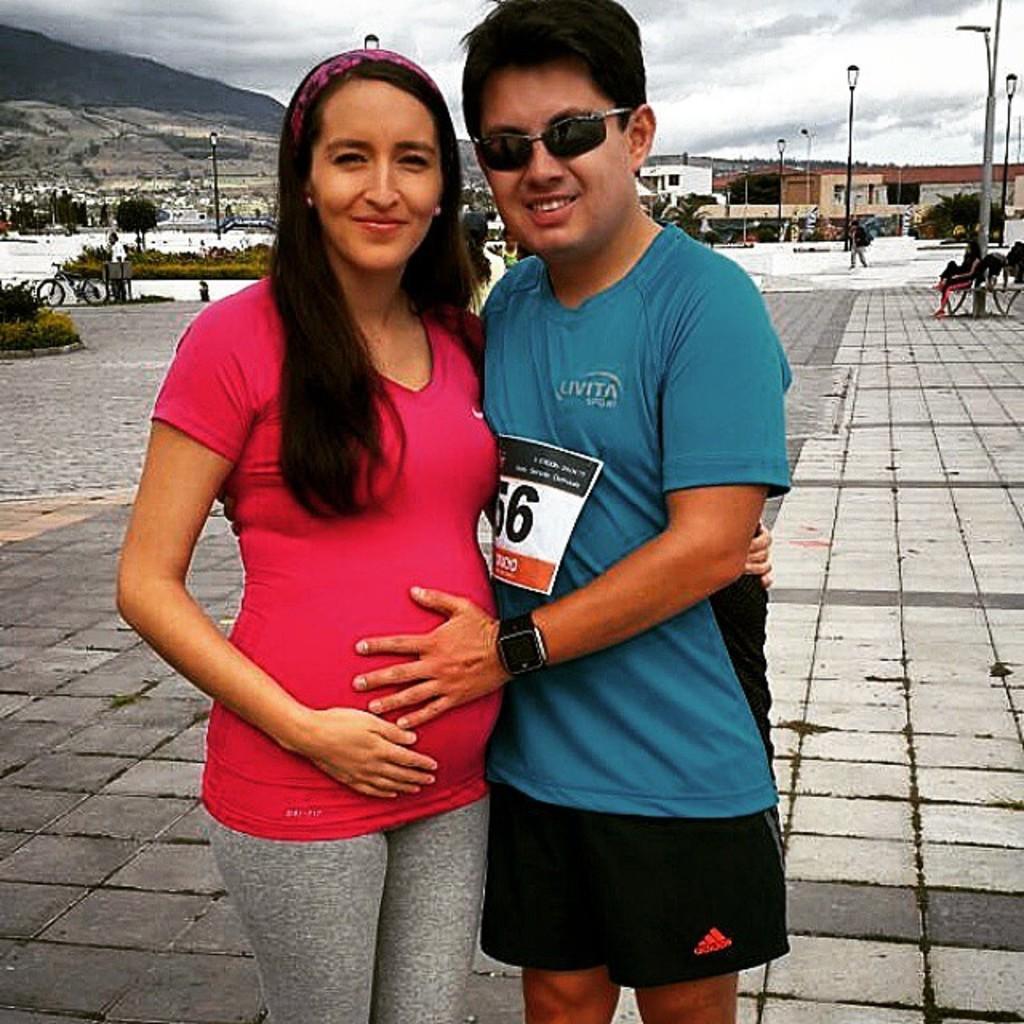Please provide a concise description of this image. This image is taken outdoors. At the bottom of the image there is a floor. At the top of the image there is a sky with clouds. On the right side of the image there are a few poles with street lights and a woman is sitting on the bench. In the background there are a few trees and plants and there is a hill. A bicycle is parked on the ground and there are a few houses with walls, windows and doors. In the middle of the image a woman and a man are standing on the ground. 